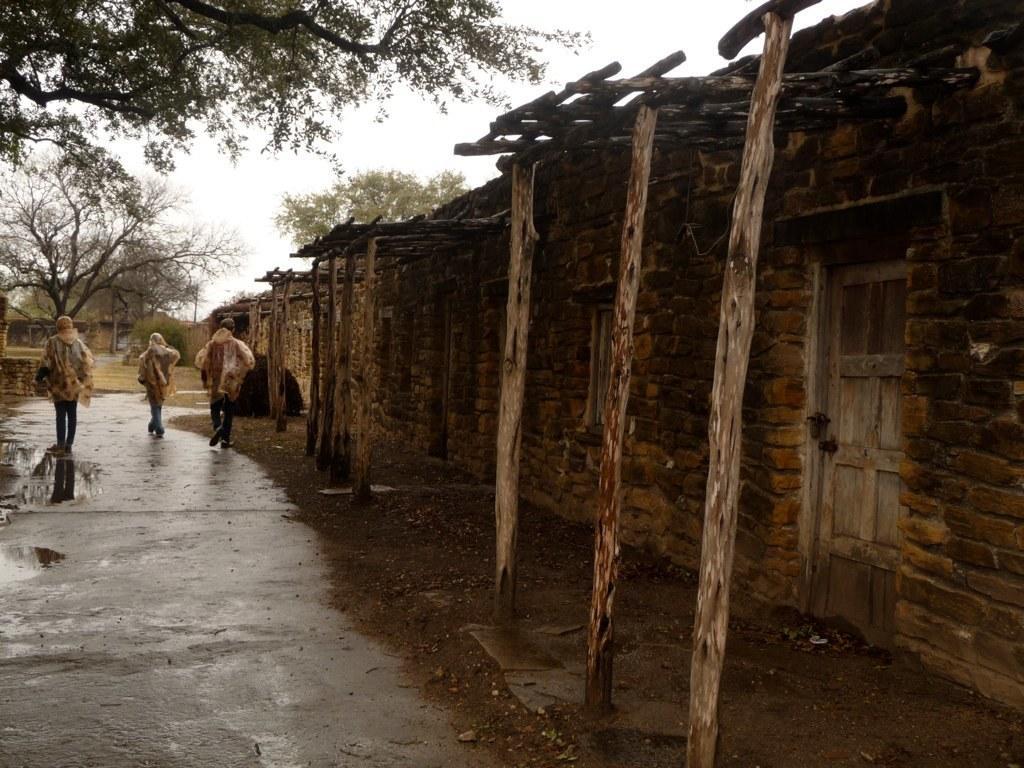Please provide a concise description of this image. There are three persons standing on the road on the left side of this image. There are some houses on the right side of this image. There are some trees in the background. There is a sky at the top of this image. 